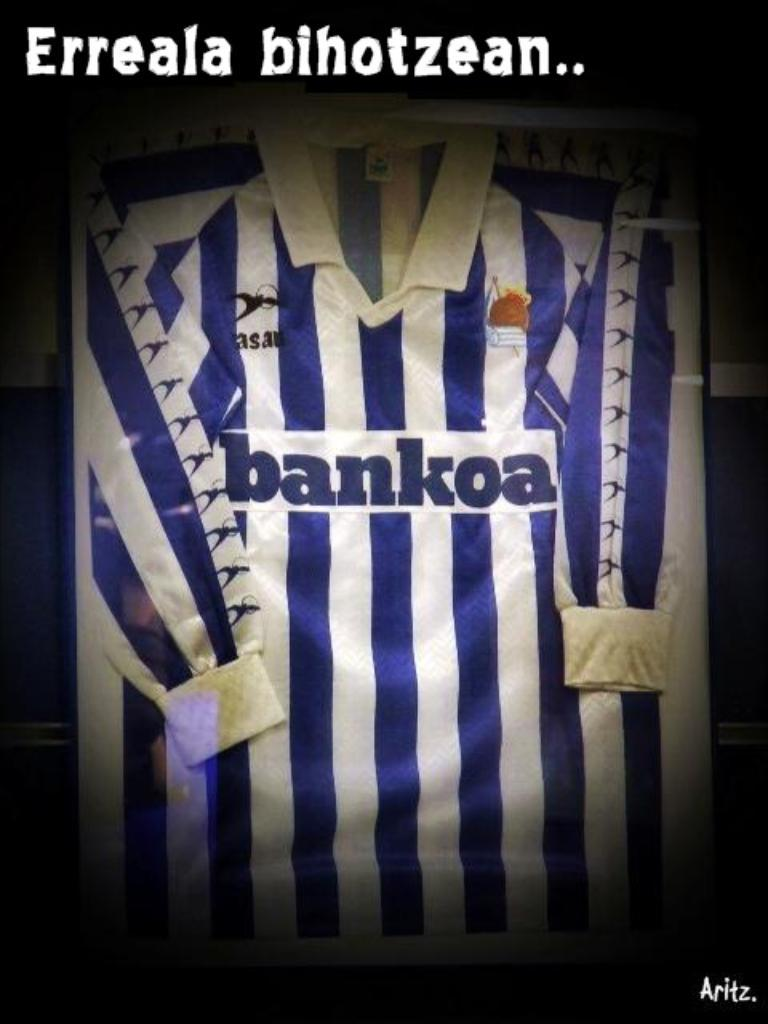<image>
Summarize the visual content of the image. a blue and white jersey with bankoa on the front 